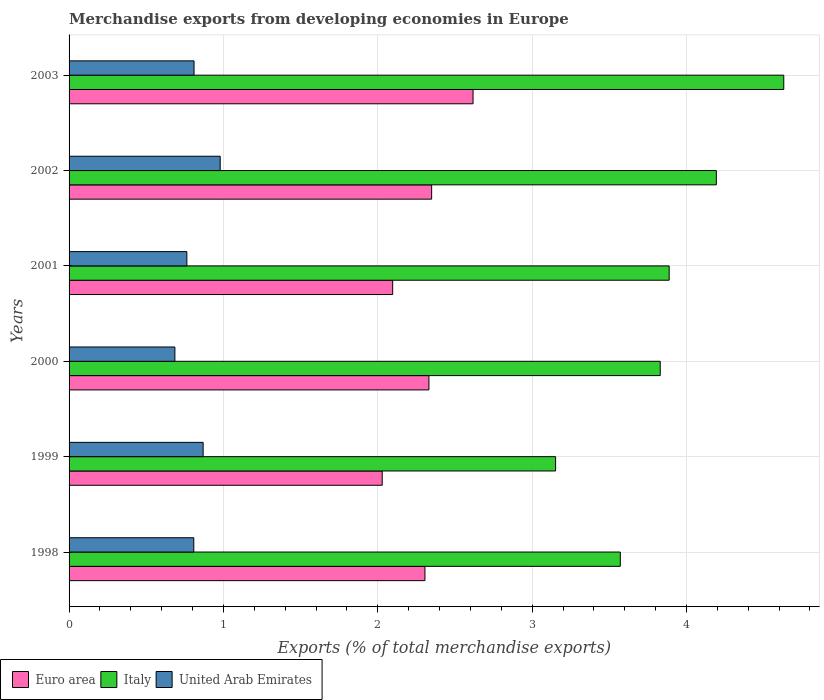Are the number of bars on each tick of the Y-axis equal?
Offer a very short reply. Yes. What is the label of the 1st group of bars from the top?
Keep it short and to the point. 2003. In how many cases, is the number of bars for a given year not equal to the number of legend labels?
Provide a short and direct response. 0. What is the percentage of total merchandise exports in Italy in 2001?
Keep it short and to the point. 3.89. Across all years, what is the maximum percentage of total merchandise exports in Euro area?
Provide a short and direct response. 2.62. Across all years, what is the minimum percentage of total merchandise exports in United Arab Emirates?
Your answer should be very brief. 0.69. What is the total percentage of total merchandise exports in Euro area in the graph?
Offer a very short reply. 13.73. What is the difference between the percentage of total merchandise exports in Euro area in 2000 and that in 2003?
Your answer should be compact. -0.29. What is the difference between the percentage of total merchandise exports in Euro area in 2001 and the percentage of total merchandise exports in United Arab Emirates in 2003?
Offer a very short reply. 1.29. What is the average percentage of total merchandise exports in United Arab Emirates per year?
Your answer should be compact. 0.82. In the year 2001, what is the difference between the percentage of total merchandise exports in Italy and percentage of total merchandise exports in Euro area?
Give a very brief answer. 1.79. In how many years, is the percentage of total merchandise exports in United Arab Emirates greater than 2.4 %?
Keep it short and to the point. 0. What is the ratio of the percentage of total merchandise exports in Italy in 1999 to that in 2003?
Ensure brevity in your answer.  0.68. What is the difference between the highest and the second highest percentage of total merchandise exports in Euro area?
Your answer should be very brief. 0.27. What is the difference between the highest and the lowest percentage of total merchandise exports in United Arab Emirates?
Your answer should be very brief. 0.29. In how many years, is the percentage of total merchandise exports in Italy greater than the average percentage of total merchandise exports in Italy taken over all years?
Keep it short and to the point. 3. Is the sum of the percentage of total merchandise exports in United Arab Emirates in 1999 and 2003 greater than the maximum percentage of total merchandise exports in Italy across all years?
Keep it short and to the point. No. What does the 2nd bar from the top in 2001 represents?
Your answer should be very brief. Italy. What does the 3rd bar from the bottom in 1998 represents?
Your answer should be very brief. United Arab Emirates. Is it the case that in every year, the sum of the percentage of total merchandise exports in United Arab Emirates and percentage of total merchandise exports in Euro area is greater than the percentage of total merchandise exports in Italy?
Ensure brevity in your answer.  No. How many bars are there?
Your answer should be very brief. 18. Are all the bars in the graph horizontal?
Your answer should be very brief. Yes. How many years are there in the graph?
Your response must be concise. 6. What is the difference between two consecutive major ticks on the X-axis?
Provide a short and direct response. 1. Does the graph contain any zero values?
Your response must be concise. No. Where does the legend appear in the graph?
Provide a succinct answer. Bottom left. What is the title of the graph?
Keep it short and to the point. Merchandise exports from developing economies in Europe. What is the label or title of the X-axis?
Keep it short and to the point. Exports (% of total merchandise exports). What is the label or title of the Y-axis?
Provide a short and direct response. Years. What is the Exports (% of total merchandise exports) in Euro area in 1998?
Your answer should be very brief. 2.31. What is the Exports (% of total merchandise exports) in Italy in 1998?
Offer a very short reply. 3.57. What is the Exports (% of total merchandise exports) in United Arab Emirates in 1998?
Provide a succinct answer. 0.81. What is the Exports (% of total merchandise exports) of Euro area in 1999?
Your answer should be compact. 2.03. What is the Exports (% of total merchandise exports) in Italy in 1999?
Your answer should be compact. 3.15. What is the Exports (% of total merchandise exports) of United Arab Emirates in 1999?
Provide a succinct answer. 0.87. What is the Exports (% of total merchandise exports) in Euro area in 2000?
Your response must be concise. 2.33. What is the Exports (% of total merchandise exports) of Italy in 2000?
Ensure brevity in your answer.  3.83. What is the Exports (% of total merchandise exports) in United Arab Emirates in 2000?
Your answer should be compact. 0.69. What is the Exports (% of total merchandise exports) in Euro area in 2001?
Give a very brief answer. 2.1. What is the Exports (% of total merchandise exports) of Italy in 2001?
Ensure brevity in your answer.  3.89. What is the Exports (% of total merchandise exports) of United Arab Emirates in 2001?
Offer a very short reply. 0.76. What is the Exports (% of total merchandise exports) of Euro area in 2002?
Provide a succinct answer. 2.35. What is the Exports (% of total merchandise exports) in Italy in 2002?
Give a very brief answer. 4.19. What is the Exports (% of total merchandise exports) in United Arab Emirates in 2002?
Keep it short and to the point. 0.98. What is the Exports (% of total merchandise exports) of Euro area in 2003?
Make the answer very short. 2.62. What is the Exports (% of total merchandise exports) of Italy in 2003?
Offer a very short reply. 4.63. What is the Exports (% of total merchandise exports) of United Arab Emirates in 2003?
Provide a short and direct response. 0.81. Across all years, what is the maximum Exports (% of total merchandise exports) in Euro area?
Keep it short and to the point. 2.62. Across all years, what is the maximum Exports (% of total merchandise exports) in Italy?
Give a very brief answer. 4.63. Across all years, what is the maximum Exports (% of total merchandise exports) of United Arab Emirates?
Make the answer very short. 0.98. Across all years, what is the minimum Exports (% of total merchandise exports) in Euro area?
Ensure brevity in your answer.  2.03. Across all years, what is the minimum Exports (% of total merchandise exports) of Italy?
Your response must be concise. 3.15. Across all years, what is the minimum Exports (% of total merchandise exports) in United Arab Emirates?
Your answer should be compact. 0.69. What is the total Exports (% of total merchandise exports) in Euro area in the graph?
Make the answer very short. 13.73. What is the total Exports (% of total merchandise exports) of Italy in the graph?
Ensure brevity in your answer.  23.26. What is the total Exports (% of total merchandise exports) of United Arab Emirates in the graph?
Offer a very short reply. 4.91. What is the difference between the Exports (% of total merchandise exports) of Euro area in 1998 and that in 1999?
Ensure brevity in your answer.  0.28. What is the difference between the Exports (% of total merchandise exports) of Italy in 1998 and that in 1999?
Offer a terse response. 0.42. What is the difference between the Exports (% of total merchandise exports) in United Arab Emirates in 1998 and that in 1999?
Offer a very short reply. -0.06. What is the difference between the Exports (% of total merchandise exports) of Euro area in 1998 and that in 2000?
Keep it short and to the point. -0.03. What is the difference between the Exports (% of total merchandise exports) of Italy in 1998 and that in 2000?
Keep it short and to the point. -0.26. What is the difference between the Exports (% of total merchandise exports) of United Arab Emirates in 1998 and that in 2000?
Provide a short and direct response. 0.12. What is the difference between the Exports (% of total merchandise exports) in Euro area in 1998 and that in 2001?
Keep it short and to the point. 0.21. What is the difference between the Exports (% of total merchandise exports) of Italy in 1998 and that in 2001?
Ensure brevity in your answer.  -0.32. What is the difference between the Exports (% of total merchandise exports) of United Arab Emirates in 1998 and that in 2001?
Your answer should be compact. 0.04. What is the difference between the Exports (% of total merchandise exports) of Euro area in 1998 and that in 2002?
Offer a terse response. -0.04. What is the difference between the Exports (% of total merchandise exports) of Italy in 1998 and that in 2002?
Give a very brief answer. -0.62. What is the difference between the Exports (% of total merchandise exports) in United Arab Emirates in 1998 and that in 2002?
Make the answer very short. -0.17. What is the difference between the Exports (% of total merchandise exports) of Euro area in 1998 and that in 2003?
Offer a terse response. -0.31. What is the difference between the Exports (% of total merchandise exports) of Italy in 1998 and that in 2003?
Ensure brevity in your answer.  -1.06. What is the difference between the Exports (% of total merchandise exports) of United Arab Emirates in 1998 and that in 2003?
Provide a succinct answer. -0. What is the difference between the Exports (% of total merchandise exports) in Euro area in 1999 and that in 2000?
Your response must be concise. -0.3. What is the difference between the Exports (% of total merchandise exports) of Italy in 1999 and that in 2000?
Give a very brief answer. -0.68. What is the difference between the Exports (% of total merchandise exports) in United Arab Emirates in 1999 and that in 2000?
Provide a short and direct response. 0.18. What is the difference between the Exports (% of total merchandise exports) in Euro area in 1999 and that in 2001?
Your answer should be very brief. -0.07. What is the difference between the Exports (% of total merchandise exports) in Italy in 1999 and that in 2001?
Provide a succinct answer. -0.74. What is the difference between the Exports (% of total merchandise exports) in United Arab Emirates in 1999 and that in 2001?
Provide a short and direct response. 0.11. What is the difference between the Exports (% of total merchandise exports) of Euro area in 1999 and that in 2002?
Provide a short and direct response. -0.32. What is the difference between the Exports (% of total merchandise exports) of Italy in 1999 and that in 2002?
Your answer should be compact. -1.04. What is the difference between the Exports (% of total merchandise exports) of United Arab Emirates in 1999 and that in 2002?
Ensure brevity in your answer.  -0.11. What is the difference between the Exports (% of total merchandise exports) in Euro area in 1999 and that in 2003?
Keep it short and to the point. -0.59. What is the difference between the Exports (% of total merchandise exports) in Italy in 1999 and that in 2003?
Offer a terse response. -1.48. What is the difference between the Exports (% of total merchandise exports) in United Arab Emirates in 1999 and that in 2003?
Ensure brevity in your answer.  0.06. What is the difference between the Exports (% of total merchandise exports) of Euro area in 2000 and that in 2001?
Ensure brevity in your answer.  0.23. What is the difference between the Exports (% of total merchandise exports) in Italy in 2000 and that in 2001?
Give a very brief answer. -0.06. What is the difference between the Exports (% of total merchandise exports) in United Arab Emirates in 2000 and that in 2001?
Offer a terse response. -0.08. What is the difference between the Exports (% of total merchandise exports) of Euro area in 2000 and that in 2002?
Keep it short and to the point. -0.02. What is the difference between the Exports (% of total merchandise exports) in Italy in 2000 and that in 2002?
Make the answer very short. -0.36. What is the difference between the Exports (% of total merchandise exports) of United Arab Emirates in 2000 and that in 2002?
Your response must be concise. -0.29. What is the difference between the Exports (% of total merchandise exports) in Euro area in 2000 and that in 2003?
Offer a very short reply. -0.29. What is the difference between the Exports (% of total merchandise exports) in Italy in 2000 and that in 2003?
Your answer should be compact. -0.8. What is the difference between the Exports (% of total merchandise exports) of United Arab Emirates in 2000 and that in 2003?
Your response must be concise. -0.12. What is the difference between the Exports (% of total merchandise exports) in Euro area in 2001 and that in 2002?
Provide a short and direct response. -0.25. What is the difference between the Exports (% of total merchandise exports) in Italy in 2001 and that in 2002?
Provide a succinct answer. -0.31. What is the difference between the Exports (% of total merchandise exports) in United Arab Emirates in 2001 and that in 2002?
Provide a succinct answer. -0.22. What is the difference between the Exports (% of total merchandise exports) in Euro area in 2001 and that in 2003?
Make the answer very short. -0.52. What is the difference between the Exports (% of total merchandise exports) of Italy in 2001 and that in 2003?
Your answer should be compact. -0.74. What is the difference between the Exports (% of total merchandise exports) of United Arab Emirates in 2001 and that in 2003?
Give a very brief answer. -0.05. What is the difference between the Exports (% of total merchandise exports) in Euro area in 2002 and that in 2003?
Provide a short and direct response. -0.27. What is the difference between the Exports (% of total merchandise exports) of Italy in 2002 and that in 2003?
Offer a very short reply. -0.44. What is the difference between the Exports (% of total merchandise exports) in United Arab Emirates in 2002 and that in 2003?
Provide a succinct answer. 0.17. What is the difference between the Exports (% of total merchandise exports) in Euro area in 1998 and the Exports (% of total merchandise exports) in Italy in 1999?
Provide a succinct answer. -0.85. What is the difference between the Exports (% of total merchandise exports) in Euro area in 1998 and the Exports (% of total merchandise exports) in United Arab Emirates in 1999?
Give a very brief answer. 1.44. What is the difference between the Exports (% of total merchandise exports) in Italy in 1998 and the Exports (% of total merchandise exports) in United Arab Emirates in 1999?
Your response must be concise. 2.7. What is the difference between the Exports (% of total merchandise exports) in Euro area in 1998 and the Exports (% of total merchandise exports) in Italy in 2000?
Provide a short and direct response. -1.52. What is the difference between the Exports (% of total merchandise exports) in Euro area in 1998 and the Exports (% of total merchandise exports) in United Arab Emirates in 2000?
Provide a succinct answer. 1.62. What is the difference between the Exports (% of total merchandise exports) in Italy in 1998 and the Exports (% of total merchandise exports) in United Arab Emirates in 2000?
Provide a short and direct response. 2.89. What is the difference between the Exports (% of total merchandise exports) of Euro area in 1998 and the Exports (% of total merchandise exports) of Italy in 2001?
Offer a very short reply. -1.58. What is the difference between the Exports (% of total merchandise exports) in Euro area in 1998 and the Exports (% of total merchandise exports) in United Arab Emirates in 2001?
Give a very brief answer. 1.54. What is the difference between the Exports (% of total merchandise exports) in Italy in 1998 and the Exports (% of total merchandise exports) in United Arab Emirates in 2001?
Provide a short and direct response. 2.81. What is the difference between the Exports (% of total merchandise exports) in Euro area in 1998 and the Exports (% of total merchandise exports) in Italy in 2002?
Keep it short and to the point. -1.89. What is the difference between the Exports (% of total merchandise exports) in Euro area in 1998 and the Exports (% of total merchandise exports) in United Arab Emirates in 2002?
Keep it short and to the point. 1.33. What is the difference between the Exports (% of total merchandise exports) in Italy in 1998 and the Exports (% of total merchandise exports) in United Arab Emirates in 2002?
Offer a terse response. 2.59. What is the difference between the Exports (% of total merchandise exports) in Euro area in 1998 and the Exports (% of total merchandise exports) in Italy in 2003?
Your response must be concise. -2.32. What is the difference between the Exports (% of total merchandise exports) in Euro area in 1998 and the Exports (% of total merchandise exports) in United Arab Emirates in 2003?
Provide a succinct answer. 1.5. What is the difference between the Exports (% of total merchandise exports) in Italy in 1998 and the Exports (% of total merchandise exports) in United Arab Emirates in 2003?
Keep it short and to the point. 2.76. What is the difference between the Exports (% of total merchandise exports) of Euro area in 1999 and the Exports (% of total merchandise exports) of Italy in 2000?
Provide a succinct answer. -1.8. What is the difference between the Exports (% of total merchandise exports) in Euro area in 1999 and the Exports (% of total merchandise exports) in United Arab Emirates in 2000?
Make the answer very short. 1.34. What is the difference between the Exports (% of total merchandise exports) of Italy in 1999 and the Exports (% of total merchandise exports) of United Arab Emirates in 2000?
Make the answer very short. 2.47. What is the difference between the Exports (% of total merchandise exports) in Euro area in 1999 and the Exports (% of total merchandise exports) in Italy in 2001?
Make the answer very short. -1.86. What is the difference between the Exports (% of total merchandise exports) in Euro area in 1999 and the Exports (% of total merchandise exports) in United Arab Emirates in 2001?
Make the answer very short. 1.27. What is the difference between the Exports (% of total merchandise exports) in Italy in 1999 and the Exports (% of total merchandise exports) in United Arab Emirates in 2001?
Provide a succinct answer. 2.39. What is the difference between the Exports (% of total merchandise exports) of Euro area in 1999 and the Exports (% of total merchandise exports) of Italy in 2002?
Provide a short and direct response. -2.16. What is the difference between the Exports (% of total merchandise exports) in Euro area in 1999 and the Exports (% of total merchandise exports) in United Arab Emirates in 2002?
Ensure brevity in your answer.  1.05. What is the difference between the Exports (% of total merchandise exports) of Italy in 1999 and the Exports (% of total merchandise exports) of United Arab Emirates in 2002?
Provide a succinct answer. 2.17. What is the difference between the Exports (% of total merchandise exports) of Euro area in 1999 and the Exports (% of total merchandise exports) of Italy in 2003?
Your response must be concise. -2.6. What is the difference between the Exports (% of total merchandise exports) in Euro area in 1999 and the Exports (% of total merchandise exports) in United Arab Emirates in 2003?
Offer a terse response. 1.22. What is the difference between the Exports (% of total merchandise exports) in Italy in 1999 and the Exports (% of total merchandise exports) in United Arab Emirates in 2003?
Keep it short and to the point. 2.34. What is the difference between the Exports (% of total merchandise exports) of Euro area in 2000 and the Exports (% of total merchandise exports) of Italy in 2001?
Ensure brevity in your answer.  -1.56. What is the difference between the Exports (% of total merchandise exports) of Euro area in 2000 and the Exports (% of total merchandise exports) of United Arab Emirates in 2001?
Your response must be concise. 1.57. What is the difference between the Exports (% of total merchandise exports) in Italy in 2000 and the Exports (% of total merchandise exports) in United Arab Emirates in 2001?
Your response must be concise. 3.07. What is the difference between the Exports (% of total merchandise exports) of Euro area in 2000 and the Exports (% of total merchandise exports) of Italy in 2002?
Your answer should be very brief. -1.86. What is the difference between the Exports (% of total merchandise exports) in Euro area in 2000 and the Exports (% of total merchandise exports) in United Arab Emirates in 2002?
Your response must be concise. 1.35. What is the difference between the Exports (% of total merchandise exports) of Italy in 2000 and the Exports (% of total merchandise exports) of United Arab Emirates in 2002?
Your answer should be compact. 2.85. What is the difference between the Exports (% of total merchandise exports) of Euro area in 2000 and the Exports (% of total merchandise exports) of Italy in 2003?
Give a very brief answer. -2.3. What is the difference between the Exports (% of total merchandise exports) in Euro area in 2000 and the Exports (% of total merchandise exports) in United Arab Emirates in 2003?
Give a very brief answer. 1.52. What is the difference between the Exports (% of total merchandise exports) in Italy in 2000 and the Exports (% of total merchandise exports) in United Arab Emirates in 2003?
Provide a succinct answer. 3.02. What is the difference between the Exports (% of total merchandise exports) in Euro area in 2001 and the Exports (% of total merchandise exports) in Italy in 2002?
Offer a terse response. -2.1. What is the difference between the Exports (% of total merchandise exports) of Euro area in 2001 and the Exports (% of total merchandise exports) of United Arab Emirates in 2002?
Keep it short and to the point. 1.12. What is the difference between the Exports (% of total merchandise exports) of Italy in 2001 and the Exports (% of total merchandise exports) of United Arab Emirates in 2002?
Offer a terse response. 2.91. What is the difference between the Exports (% of total merchandise exports) of Euro area in 2001 and the Exports (% of total merchandise exports) of Italy in 2003?
Provide a succinct answer. -2.53. What is the difference between the Exports (% of total merchandise exports) of Euro area in 2001 and the Exports (% of total merchandise exports) of United Arab Emirates in 2003?
Offer a terse response. 1.29. What is the difference between the Exports (% of total merchandise exports) in Italy in 2001 and the Exports (% of total merchandise exports) in United Arab Emirates in 2003?
Provide a succinct answer. 3.08. What is the difference between the Exports (% of total merchandise exports) in Euro area in 2002 and the Exports (% of total merchandise exports) in Italy in 2003?
Keep it short and to the point. -2.28. What is the difference between the Exports (% of total merchandise exports) of Euro area in 2002 and the Exports (% of total merchandise exports) of United Arab Emirates in 2003?
Offer a terse response. 1.54. What is the difference between the Exports (% of total merchandise exports) of Italy in 2002 and the Exports (% of total merchandise exports) of United Arab Emirates in 2003?
Make the answer very short. 3.38. What is the average Exports (% of total merchandise exports) of Euro area per year?
Your response must be concise. 2.29. What is the average Exports (% of total merchandise exports) of Italy per year?
Provide a succinct answer. 3.88. What is the average Exports (% of total merchandise exports) in United Arab Emirates per year?
Keep it short and to the point. 0.82. In the year 1998, what is the difference between the Exports (% of total merchandise exports) of Euro area and Exports (% of total merchandise exports) of Italy?
Ensure brevity in your answer.  -1.27. In the year 1998, what is the difference between the Exports (% of total merchandise exports) in Euro area and Exports (% of total merchandise exports) in United Arab Emirates?
Give a very brief answer. 1.5. In the year 1998, what is the difference between the Exports (% of total merchandise exports) in Italy and Exports (% of total merchandise exports) in United Arab Emirates?
Give a very brief answer. 2.76. In the year 1999, what is the difference between the Exports (% of total merchandise exports) of Euro area and Exports (% of total merchandise exports) of Italy?
Keep it short and to the point. -1.12. In the year 1999, what is the difference between the Exports (% of total merchandise exports) of Euro area and Exports (% of total merchandise exports) of United Arab Emirates?
Offer a very short reply. 1.16. In the year 1999, what is the difference between the Exports (% of total merchandise exports) in Italy and Exports (% of total merchandise exports) in United Arab Emirates?
Ensure brevity in your answer.  2.28. In the year 2000, what is the difference between the Exports (% of total merchandise exports) of Euro area and Exports (% of total merchandise exports) of Italy?
Ensure brevity in your answer.  -1.5. In the year 2000, what is the difference between the Exports (% of total merchandise exports) of Euro area and Exports (% of total merchandise exports) of United Arab Emirates?
Offer a very short reply. 1.65. In the year 2000, what is the difference between the Exports (% of total merchandise exports) in Italy and Exports (% of total merchandise exports) in United Arab Emirates?
Give a very brief answer. 3.14. In the year 2001, what is the difference between the Exports (% of total merchandise exports) of Euro area and Exports (% of total merchandise exports) of Italy?
Provide a succinct answer. -1.79. In the year 2001, what is the difference between the Exports (% of total merchandise exports) of Euro area and Exports (% of total merchandise exports) of United Arab Emirates?
Provide a short and direct response. 1.33. In the year 2001, what is the difference between the Exports (% of total merchandise exports) in Italy and Exports (% of total merchandise exports) in United Arab Emirates?
Ensure brevity in your answer.  3.12. In the year 2002, what is the difference between the Exports (% of total merchandise exports) of Euro area and Exports (% of total merchandise exports) of Italy?
Your response must be concise. -1.84. In the year 2002, what is the difference between the Exports (% of total merchandise exports) in Euro area and Exports (% of total merchandise exports) in United Arab Emirates?
Provide a succinct answer. 1.37. In the year 2002, what is the difference between the Exports (% of total merchandise exports) of Italy and Exports (% of total merchandise exports) of United Arab Emirates?
Make the answer very short. 3.21. In the year 2003, what is the difference between the Exports (% of total merchandise exports) in Euro area and Exports (% of total merchandise exports) in Italy?
Provide a short and direct response. -2.01. In the year 2003, what is the difference between the Exports (% of total merchandise exports) of Euro area and Exports (% of total merchandise exports) of United Arab Emirates?
Ensure brevity in your answer.  1.81. In the year 2003, what is the difference between the Exports (% of total merchandise exports) of Italy and Exports (% of total merchandise exports) of United Arab Emirates?
Provide a succinct answer. 3.82. What is the ratio of the Exports (% of total merchandise exports) of Euro area in 1998 to that in 1999?
Keep it short and to the point. 1.14. What is the ratio of the Exports (% of total merchandise exports) in Italy in 1998 to that in 1999?
Your answer should be compact. 1.13. What is the ratio of the Exports (% of total merchandise exports) of United Arab Emirates in 1998 to that in 1999?
Make the answer very short. 0.93. What is the ratio of the Exports (% of total merchandise exports) of Euro area in 1998 to that in 2000?
Your response must be concise. 0.99. What is the ratio of the Exports (% of total merchandise exports) in Italy in 1998 to that in 2000?
Offer a terse response. 0.93. What is the ratio of the Exports (% of total merchandise exports) of United Arab Emirates in 1998 to that in 2000?
Give a very brief answer. 1.18. What is the ratio of the Exports (% of total merchandise exports) of Euro area in 1998 to that in 2001?
Offer a terse response. 1.1. What is the ratio of the Exports (% of total merchandise exports) in Italy in 1998 to that in 2001?
Ensure brevity in your answer.  0.92. What is the ratio of the Exports (% of total merchandise exports) in United Arab Emirates in 1998 to that in 2001?
Offer a terse response. 1.06. What is the ratio of the Exports (% of total merchandise exports) in Euro area in 1998 to that in 2002?
Give a very brief answer. 0.98. What is the ratio of the Exports (% of total merchandise exports) in Italy in 1998 to that in 2002?
Offer a very short reply. 0.85. What is the ratio of the Exports (% of total merchandise exports) in United Arab Emirates in 1998 to that in 2002?
Ensure brevity in your answer.  0.83. What is the ratio of the Exports (% of total merchandise exports) of Euro area in 1998 to that in 2003?
Ensure brevity in your answer.  0.88. What is the ratio of the Exports (% of total merchandise exports) in Italy in 1998 to that in 2003?
Provide a succinct answer. 0.77. What is the ratio of the Exports (% of total merchandise exports) of Euro area in 1999 to that in 2000?
Offer a terse response. 0.87. What is the ratio of the Exports (% of total merchandise exports) of Italy in 1999 to that in 2000?
Give a very brief answer. 0.82. What is the ratio of the Exports (% of total merchandise exports) in United Arab Emirates in 1999 to that in 2000?
Your response must be concise. 1.27. What is the ratio of the Exports (% of total merchandise exports) of Euro area in 1999 to that in 2001?
Your answer should be very brief. 0.97. What is the ratio of the Exports (% of total merchandise exports) in Italy in 1999 to that in 2001?
Offer a very short reply. 0.81. What is the ratio of the Exports (% of total merchandise exports) in United Arab Emirates in 1999 to that in 2001?
Make the answer very short. 1.14. What is the ratio of the Exports (% of total merchandise exports) of Euro area in 1999 to that in 2002?
Your answer should be compact. 0.86. What is the ratio of the Exports (% of total merchandise exports) in Italy in 1999 to that in 2002?
Your response must be concise. 0.75. What is the ratio of the Exports (% of total merchandise exports) of United Arab Emirates in 1999 to that in 2002?
Your answer should be very brief. 0.89. What is the ratio of the Exports (% of total merchandise exports) in Euro area in 1999 to that in 2003?
Offer a terse response. 0.78. What is the ratio of the Exports (% of total merchandise exports) in Italy in 1999 to that in 2003?
Offer a very short reply. 0.68. What is the ratio of the Exports (% of total merchandise exports) in United Arab Emirates in 1999 to that in 2003?
Provide a succinct answer. 1.07. What is the ratio of the Exports (% of total merchandise exports) of Euro area in 2000 to that in 2001?
Your answer should be very brief. 1.11. What is the ratio of the Exports (% of total merchandise exports) of Italy in 2000 to that in 2001?
Offer a terse response. 0.99. What is the ratio of the Exports (% of total merchandise exports) of United Arab Emirates in 2000 to that in 2001?
Keep it short and to the point. 0.9. What is the ratio of the Exports (% of total merchandise exports) in Euro area in 2000 to that in 2002?
Provide a short and direct response. 0.99. What is the ratio of the Exports (% of total merchandise exports) in Italy in 2000 to that in 2002?
Provide a succinct answer. 0.91. What is the ratio of the Exports (% of total merchandise exports) of United Arab Emirates in 2000 to that in 2002?
Provide a short and direct response. 0.7. What is the ratio of the Exports (% of total merchandise exports) of Euro area in 2000 to that in 2003?
Your answer should be very brief. 0.89. What is the ratio of the Exports (% of total merchandise exports) of Italy in 2000 to that in 2003?
Provide a succinct answer. 0.83. What is the ratio of the Exports (% of total merchandise exports) in United Arab Emirates in 2000 to that in 2003?
Ensure brevity in your answer.  0.85. What is the ratio of the Exports (% of total merchandise exports) of Euro area in 2001 to that in 2002?
Your answer should be compact. 0.89. What is the ratio of the Exports (% of total merchandise exports) in Italy in 2001 to that in 2002?
Provide a short and direct response. 0.93. What is the ratio of the Exports (% of total merchandise exports) in United Arab Emirates in 2001 to that in 2002?
Your answer should be very brief. 0.78. What is the ratio of the Exports (% of total merchandise exports) of Euro area in 2001 to that in 2003?
Your answer should be compact. 0.8. What is the ratio of the Exports (% of total merchandise exports) of Italy in 2001 to that in 2003?
Provide a short and direct response. 0.84. What is the ratio of the Exports (% of total merchandise exports) in United Arab Emirates in 2001 to that in 2003?
Keep it short and to the point. 0.94. What is the ratio of the Exports (% of total merchandise exports) in Euro area in 2002 to that in 2003?
Your response must be concise. 0.9. What is the ratio of the Exports (% of total merchandise exports) in Italy in 2002 to that in 2003?
Keep it short and to the point. 0.91. What is the ratio of the Exports (% of total merchandise exports) of United Arab Emirates in 2002 to that in 2003?
Provide a succinct answer. 1.21. What is the difference between the highest and the second highest Exports (% of total merchandise exports) of Euro area?
Offer a very short reply. 0.27. What is the difference between the highest and the second highest Exports (% of total merchandise exports) in Italy?
Your answer should be compact. 0.44. What is the difference between the highest and the second highest Exports (% of total merchandise exports) in United Arab Emirates?
Offer a very short reply. 0.11. What is the difference between the highest and the lowest Exports (% of total merchandise exports) in Euro area?
Your response must be concise. 0.59. What is the difference between the highest and the lowest Exports (% of total merchandise exports) of Italy?
Offer a very short reply. 1.48. What is the difference between the highest and the lowest Exports (% of total merchandise exports) of United Arab Emirates?
Provide a short and direct response. 0.29. 